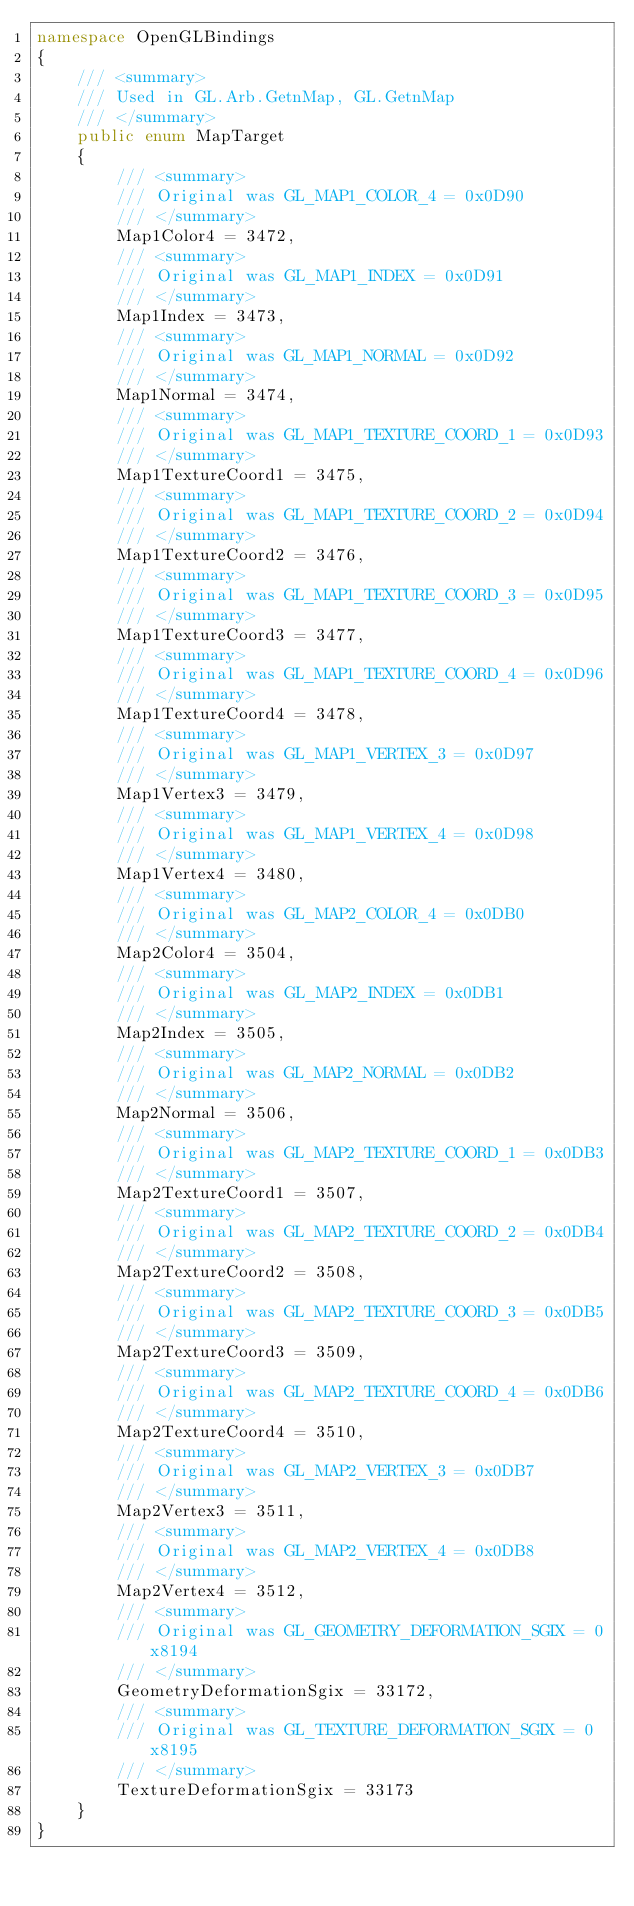<code> <loc_0><loc_0><loc_500><loc_500><_C#_>namespace OpenGLBindings
{
    /// <summary>
    /// Used in GL.Arb.GetnMap, GL.GetnMap
    /// </summary>
    public enum MapTarget
    {
        /// <summary>
        /// Original was GL_MAP1_COLOR_4 = 0x0D90
        /// </summary>
        Map1Color4 = 3472,
        /// <summary>
        /// Original was GL_MAP1_INDEX = 0x0D91
        /// </summary>
        Map1Index = 3473,
        /// <summary>
        /// Original was GL_MAP1_NORMAL = 0x0D92
        /// </summary>
        Map1Normal = 3474,
        /// <summary>
        /// Original was GL_MAP1_TEXTURE_COORD_1 = 0x0D93
        /// </summary>
        Map1TextureCoord1 = 3475,
        /// <summary>
        /// Original was GL_MAP1_TEXTURE_COORD_2 = 0x0D94
        /// </summary>
        Map1TextureCoord2 = 3476,
        /// <summary>
        /// Original was GL_MAP1_TEXTURE_COORD_3 = 0x0D95
        /// </summary>
        Map1TextureCoord3 = 3477,
        /// <summary>
        /// Original was GL_MAP1_TEXTURE_COORD_4 = 0x0D96
        /// </summary>
        Map1TextureCoord4 = 3478,
        /// <summary>
        /// Original was GL_MAP1_VERTEX_3 = 0x0D97
        /// </summary>
        Map1Vertex3 = 3479,
        /// <summary>
        /// Original was GL_MAP1_VERTEX_4 = 0x0D98
        /// </summary>
        Map1Vertex4 = 3480,
        /// <summary>
        /// Original was GL_MAP2_COLOR_4 = 0x0DB0
        /// </summary>
        Map2Color4 = 3504,
        /// <summary>
        /// Original was GL_MAP2_INDEX = 0x0DB1
        /// </summary>
        Map2Index = 3505,
        /// <summary>
        /// Original was GL_MAP2_NORMAL = 0x0DB2
        /// </summary>
        Map2Normal = 3506,
        /// <summary>
        /// Original was GL_MAP2_TEXTURE_COORD_1 = 0x0DB3
        /// </summary>
        Map2TextureCoord1 = 3507,
        /// <summary>
        /// Original was GL_MAP2_TEXTURE_COORD_2 = 0x0DB4
        /// </summary>
        Map2TextureCoord2 = 3508,
        /// <summary>
        /// Original was GL_MAP2_TEXTURE_COORD_3 = 0x0DB5
        /// </summary>
        Map2TextureCoord3 = 3509,
        /// <summary>
        /// Original was GL_MAP2_TEXTURE_COORD_4 = 0x0DB6
        /// </summary>
        Map2TextureCoord4 = 3510,
        /// <summary>
        /// Original was GL_MAP2_VERTEX_3 = 0x0DB7
        /// </summary>
        Map2Vertex3 = 3511,
        /// <summary>
        /// Original was GL_MAP2_VERTEX_4 = 0x0DB8
        /// </summary>
        Map2Vertex4 = 3512,
        /// <summary>
        /// Original was GL_GEOMETRY_DEFORMATION_SGIX = 0x8194
        /// </summary>
        GeometryDeformationSgix = 33172,
        /// <summary>
        /// Original was GL_TEXTURE_DEFORMATION_SGIX = 0x8195
        /// </summary>
        TextureDeformationSgix = 33173
    }
}</code> 